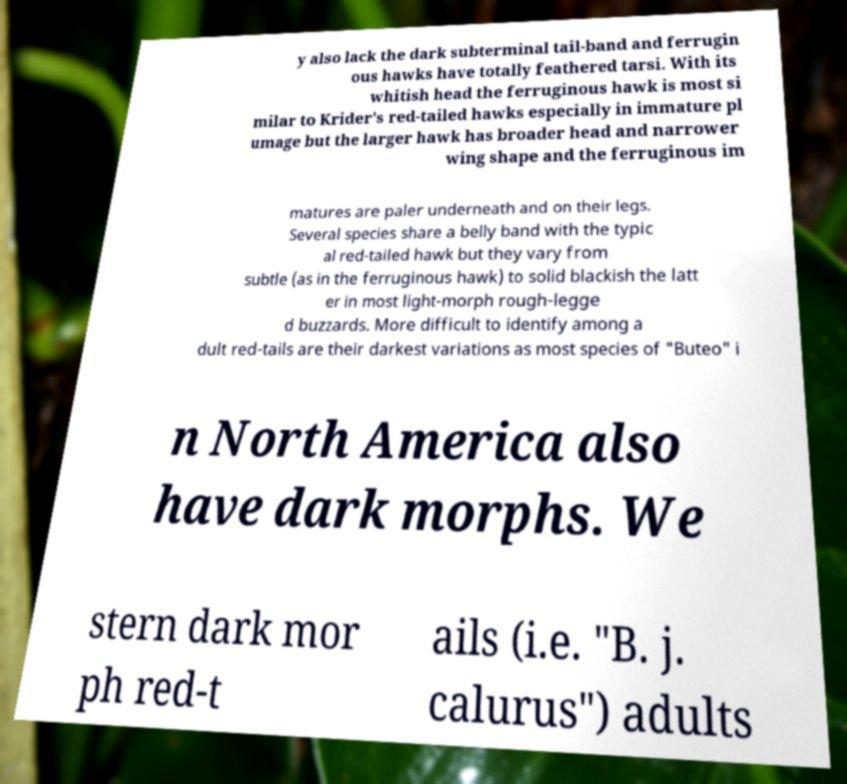Can you accurately transcribe the text from the provided image for me? y also lack the dark subterminal tail-band and ferrugin ous hawks have totally feathered tarsi. With its whitish head the ferruginous hawk is most si milar to Krider's red-tailed hawks especially in immature pl umage but the larger hawk has broader head and narrower wing shape and the ferruginous im matures are paler underneath and on their legs. Several species share a belly band with the typic al red-tailed hawk but they vary from subtle (as in the ferruginous hawk) to solid blackish the latt er in most light-morph rough-legge d buzzards. More difficult to identify among a dult red-tails are their darkest variations as most species of "Buteo" i n North America also have dark morphs. We stern dark mor ph red-t ails (i.e. "B. j. calurus") adults 